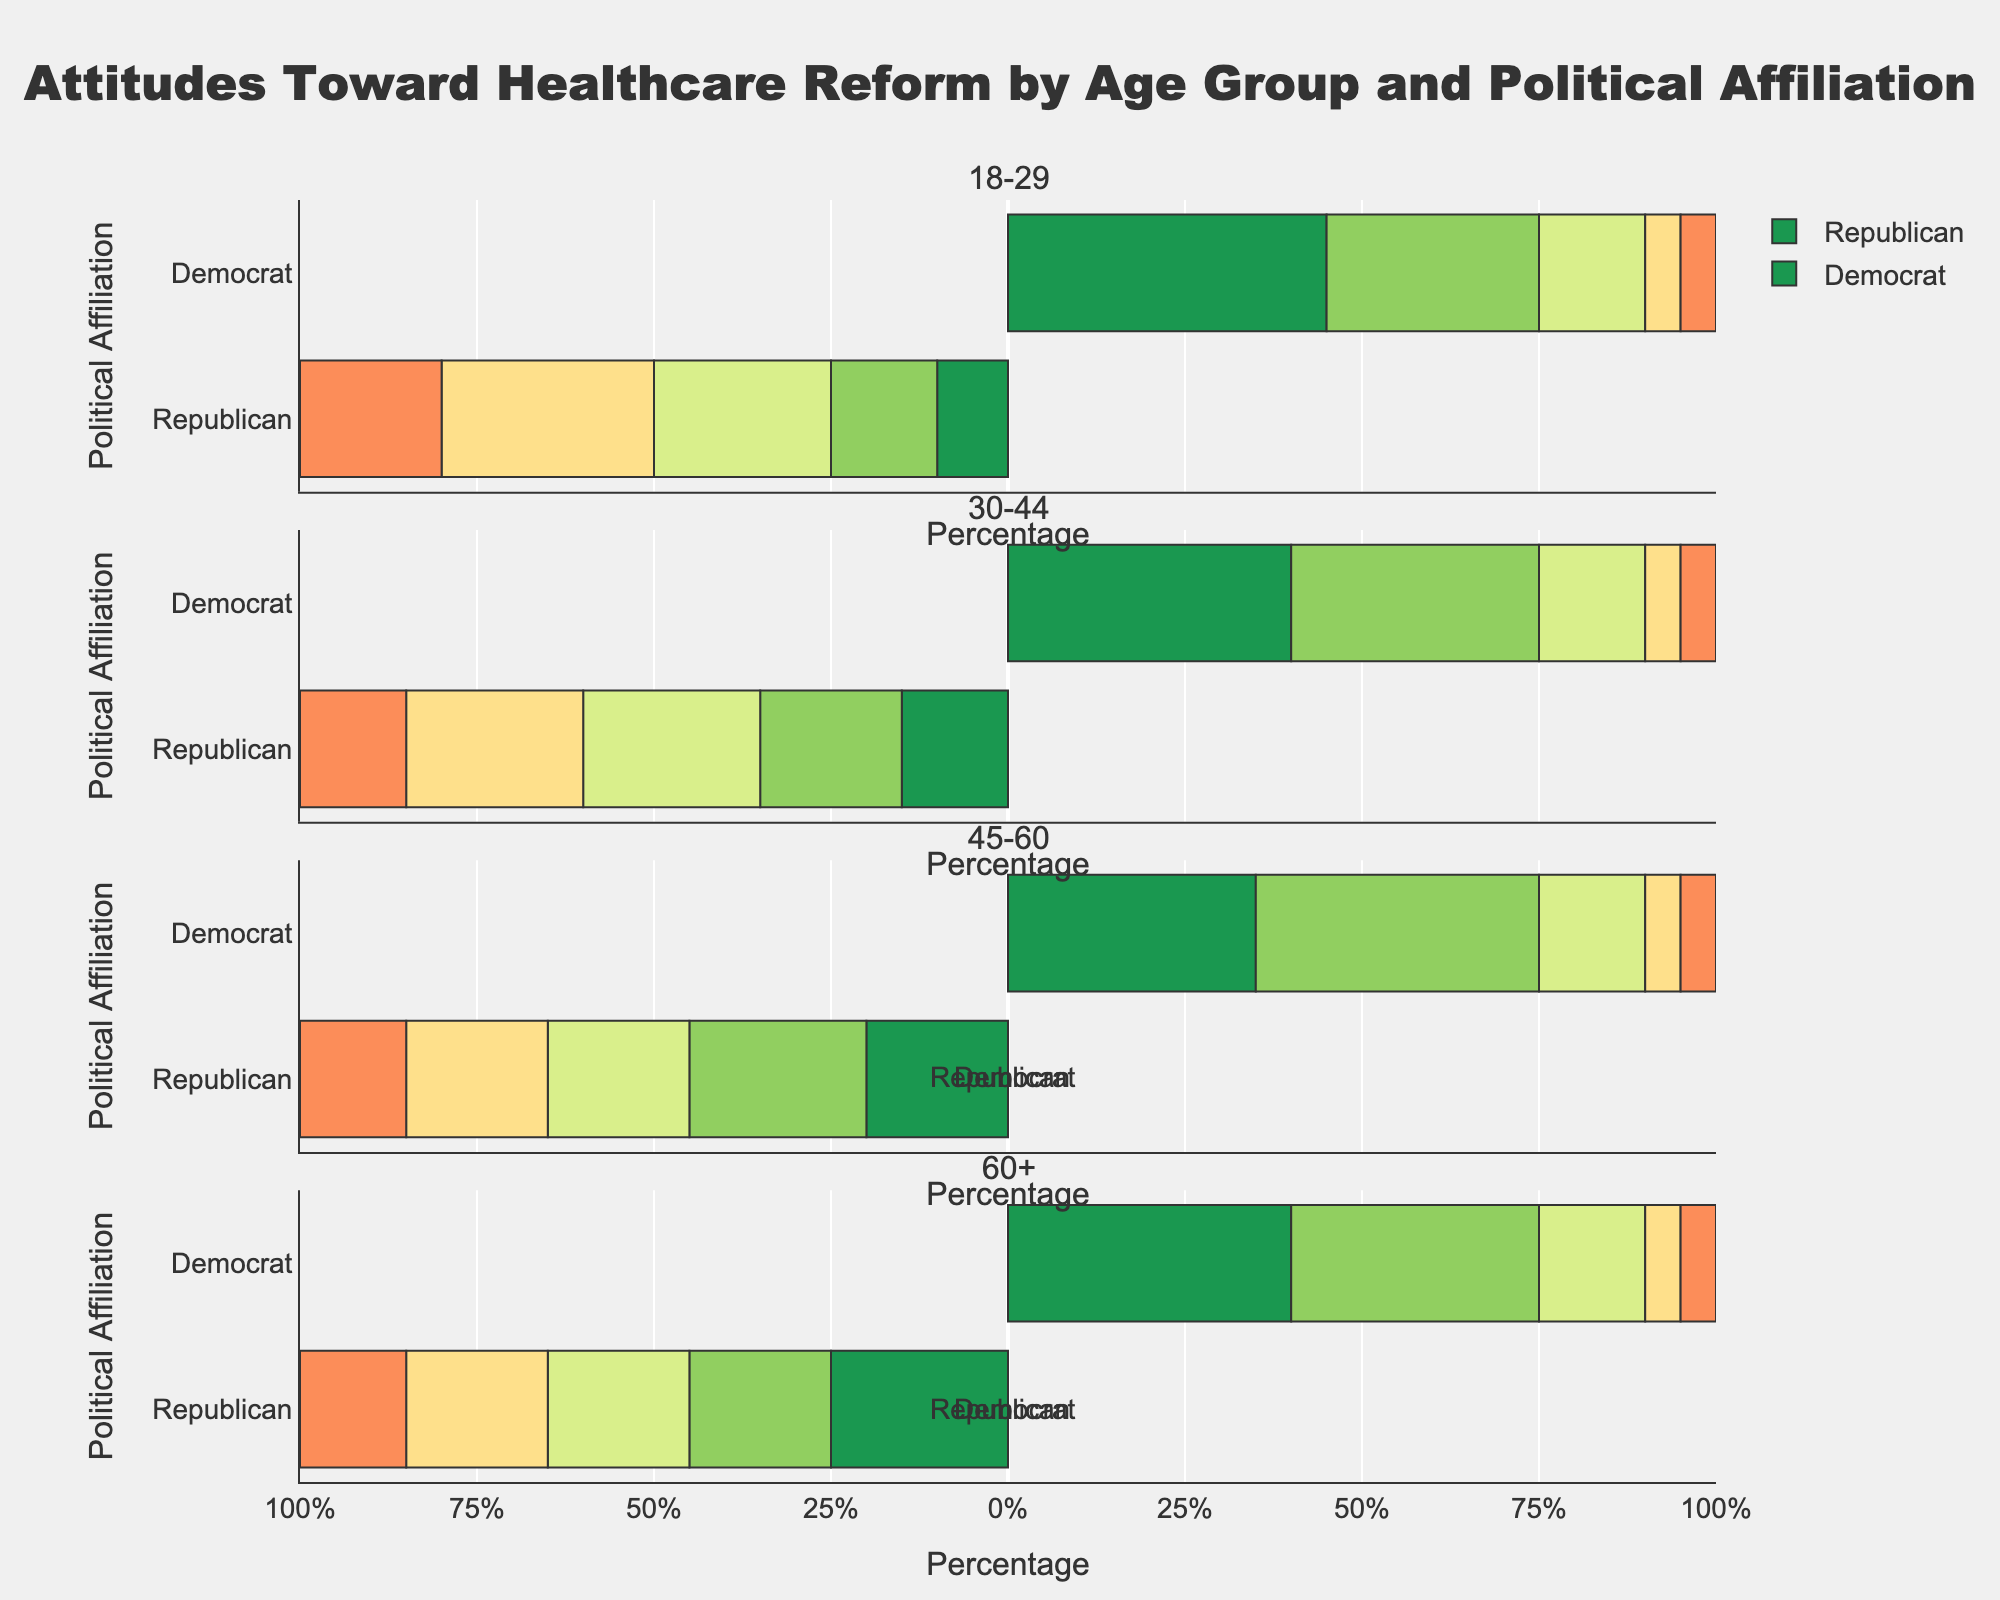What are the differences in "Strongly Support" between 18-29 and 60+ Republican voters? For 18-29 Republicans, "Strongly Support" is 10%, while for 60+ Republicans, it's 25%. The difference is 25% - 10% = 15%.
Answer: 15% Which age group has the highest level of "Strongly Oppose" among Democrats? By comparing the "Strongly Oppose" values for Democrats across all age groups (all being 5%), no single group has a higher value than the others.
Answer: None How does the level of "Neutral" compare between 30-44 Republicans and 45-60 Republicans? Both age groups have "Neutral" values of 25% and 20%, respectively.
Answer: 30-44 Republicans have 5% more What is the combined percentage of Republicans who "Support" and "Strongly Support" healthcare reform in the 45-60 age group? For 45-60 Republicans, "Support" is 25% and "Strongly Support" is 20%. The combined percentage is 25% + 20% = 45%.
Answer: 45% How do the "Support" percentages compare between the youngest and oldest Democrats? The youngest (18-29) Democrats have a "Support" percentage of 30%, while the oldest (60+) have 35%.
Answer: Older Democrats have 5% more Which group has the lowest percentage of "Oppose" within the Republican voters? The "Oppose" percentages for Republican voters are: 30% (18-29), 25% (30-44), 20% (45-60), and 20% (60+). The lowest is among 45-60 and 60+ Republicans.
Answer: 45-60 and 60+ Republicans What is the ratio of "Strongly Support" to "Strongly Oppose" among 30-44 Democrats? For 30-44 Democrats, "Strongly Support" is 40% and "Strongly Oppose" is 5%. The ratio is 40/5 = 8.
Answer: 8 Compare the aggregate support (both "Strongly Support" and "Support") for healthcare reform between 18-29 Democrats and 45-60 Democrats. For 18-29 Democrats: 45% + 30% = 75%. For 45-60 Democrats: 35% + 40% = 75%. The aggregate support is the same.
Answer: Equal at 75% What is the trend in "Oppose" percentages among Republicans as the age group increases? The "Oppose" percentages for Republicans are: 30% (18-29), 25% (30-44), 20% (45-60), and 20% (60+). The trend shows a decrease from 18-29 to 45-60 and stabilizes afterward.
Answer: Decreasing, then stable Which age group among Republicans has the highest combined percentage of "Neutral" and "Oppose"? Adding the "Neutral" and "Oppose" percentages: 18-29 (25% + 30% = 55%), 30-44 (25% + 25% = 50%), 45-60 (20% + 20% = 40%), and 60+ (20% + 20% = 40%). The highest combined percentage is among 18-29 Republicans.
Answer: 18-29 Republicans 